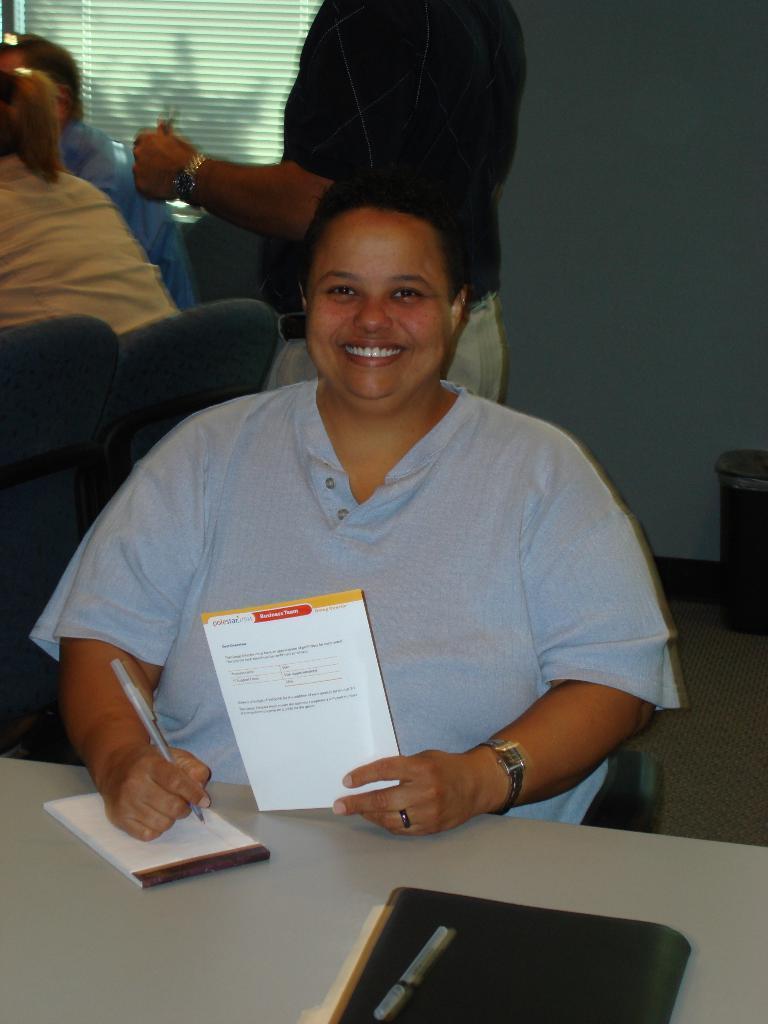Can you describe this image briefly? In this image there is a person sitting on the chair and holding a pen and a paper, there are books and a pen on the table, and in the background there is a person standing, two persons sitting on the chairs , and there is a wall. 